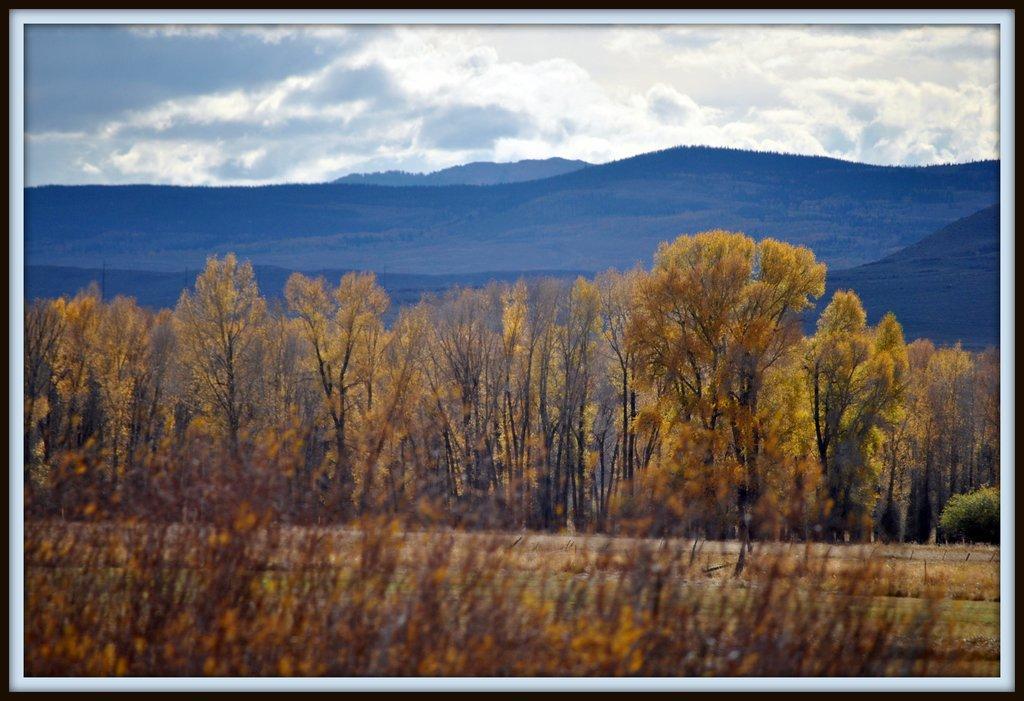Can you describe this image briefly? It is a photo frame, in this there are trees and hills. At the top it is a cloudy sky. 